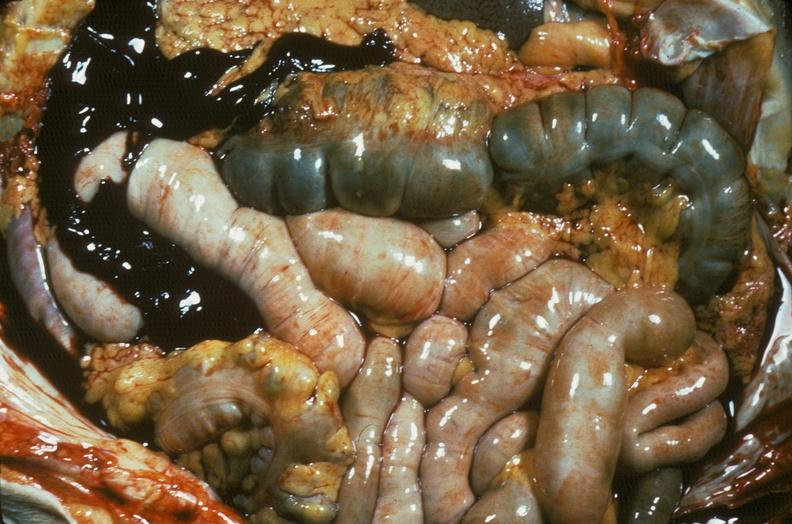where is this area in the body?
Answer the question using a single word or phrase. Abdomen 